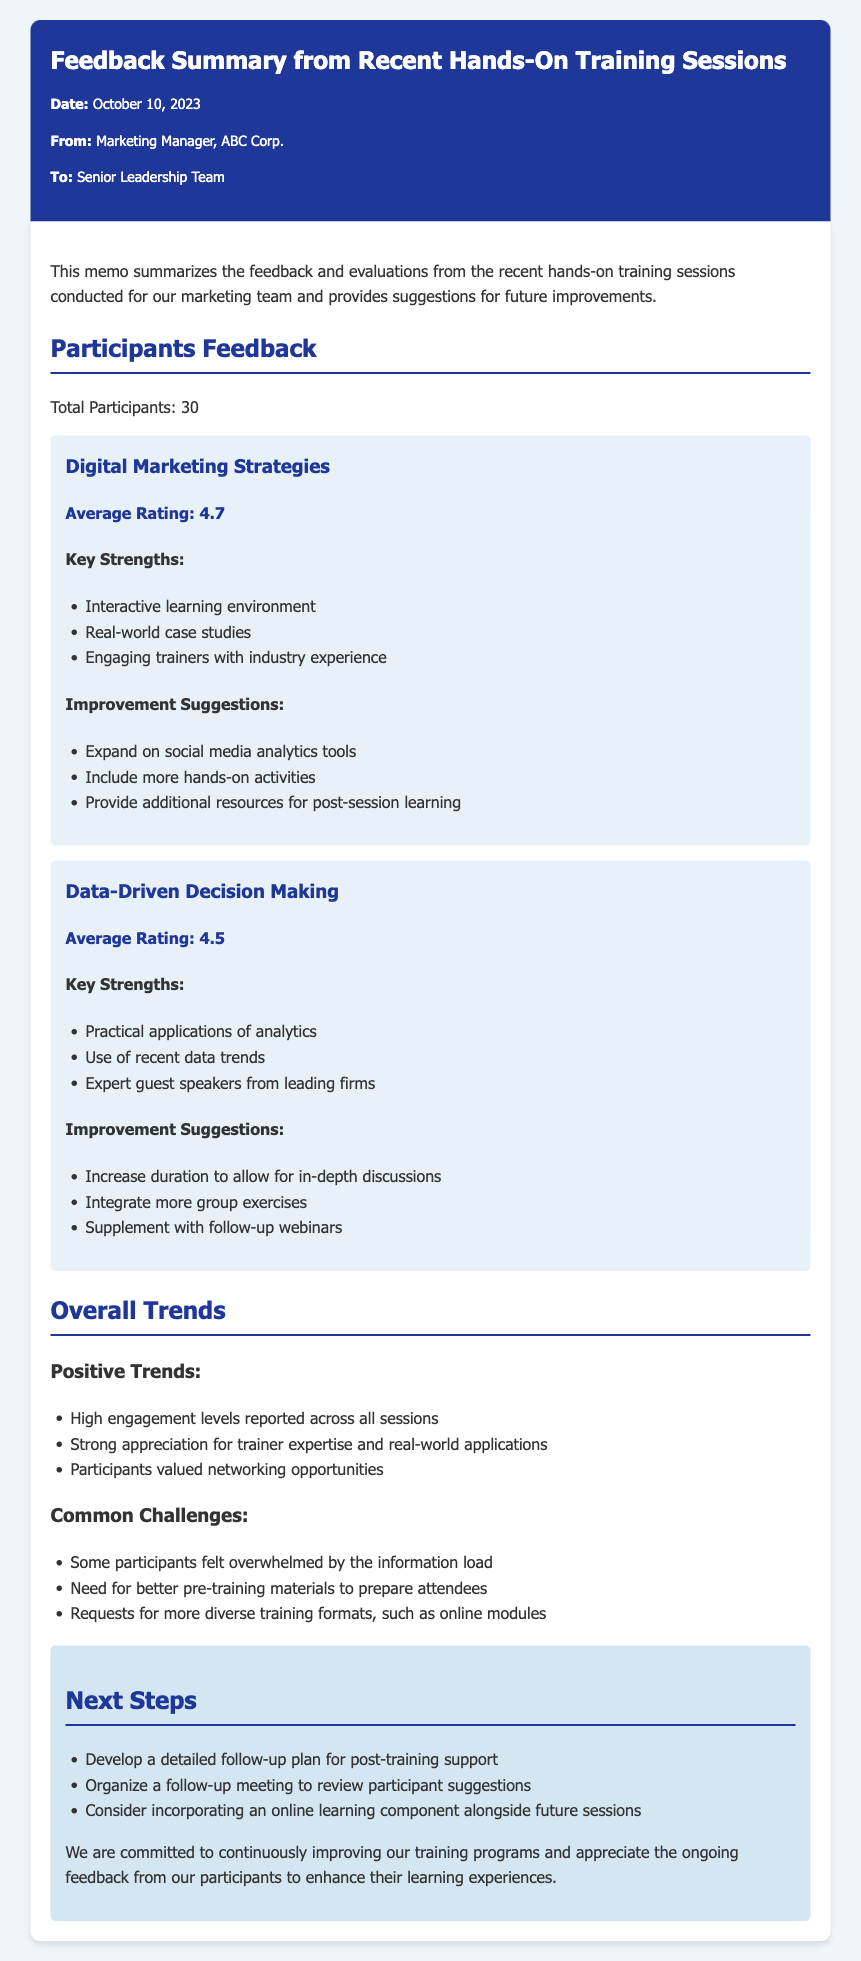What is the date of the memo? The date of the memo is clearly stated in the header section of the document.
Answer: October 10, 2023 Who is the memo addressed to? The "To" section of the memo specifies the recipient of the communication.
Answer: Senior Leadership Team How many participants were there? The total number of participants is mentioned in the Participants Feedback section.
Answer: 30 What was the average rating for Digital Marketing Strategies? The average rating for each session is provided in the respective sections, specifically for Digital Marketing Strategies.
Answer: 4.7 What positive trend was reported? Positive trends are listed under the Overall Trends section, bringing attention to participant experiences.
Answer: High engagement levels reported across all sessions What was a common challenge mentioned? Common challenges are outlined in the Overall Trends section, highlighting participant feedback.
Answer: Some participants felt overwhelmed by the information load What improvement suggestion was made for Data-Driven Decision Making? The Improvement Suggestions section for each training session includes recommendations from participants.
Answer: Increase duration to allow for in-depth discussions What is one of the next steps proposed? The Next Steps section provides a clear outline of future actions to be taken in response to the feedback.
Answer: Develop a detailed follow-up plan for post-training support 